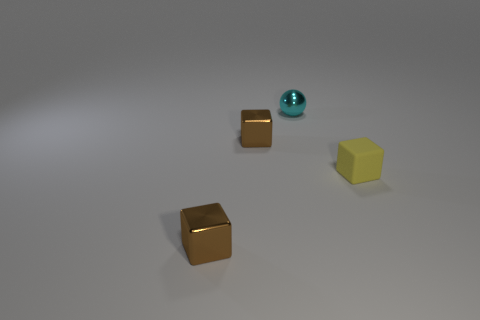Add 1 brown rubber cylinders. How many objects exist? 5 Subtract all brown blocks. How many blocks are left? 1 Subtract 1 balls. How many balls are left? 0 Subtract all yellow cubes. How many cubes are left? 2 Subtract all shiny spheres. Subtract all yellow rubber objects. How many objects are left? 2 Add 1 matte cubes. How many matte cubes are left? 2 Add 2 tiny brown shiny things. How many tiny brown shiny things exist? 4 Subtract 0 blue cylinders. How many objects are left? 4 Subtract all cubes. How many objects are left? 1 Subtract all gray cubes. Subtract all cyan balls. How many cubes are left? 3 